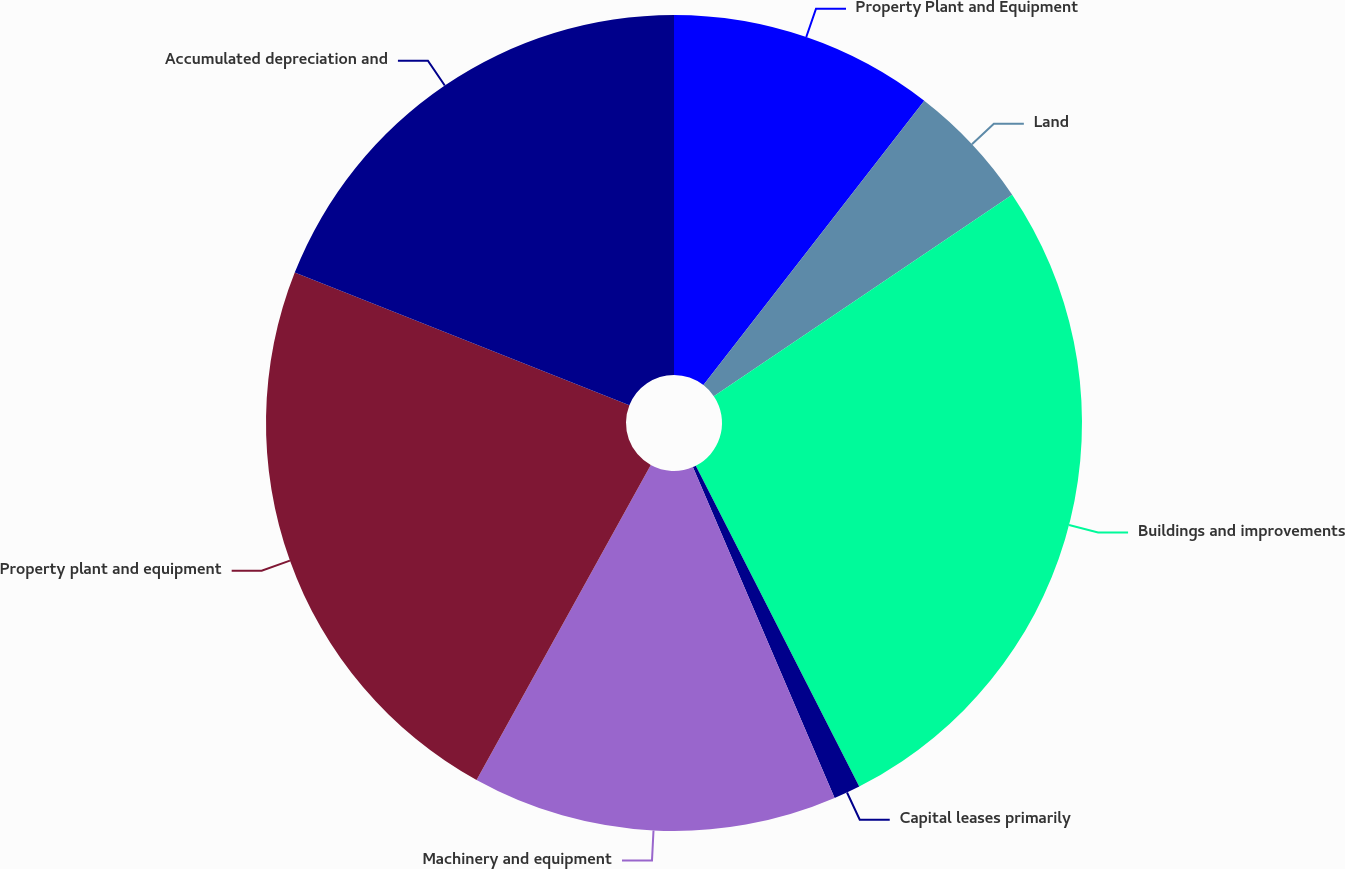Convert chart to OTSL. <chart><loc_0><loc_0><loc_500><loc_500><pie_chart><fcel>Property Plant and Equipment<fcel>Land<fcel>Buildings and improvements<fcel>Capital leases primarily<fcel>Machinery and equipment<fcel>Property plant and equipment<fcel>Accumulated depreciation and<nl><fcel>10.51%<fcel>5.04%<fcel>26.95%<fcel>1.06%<fcel>14.48%<fcel>22.97%<fcel>18.99%<nl></chart> 